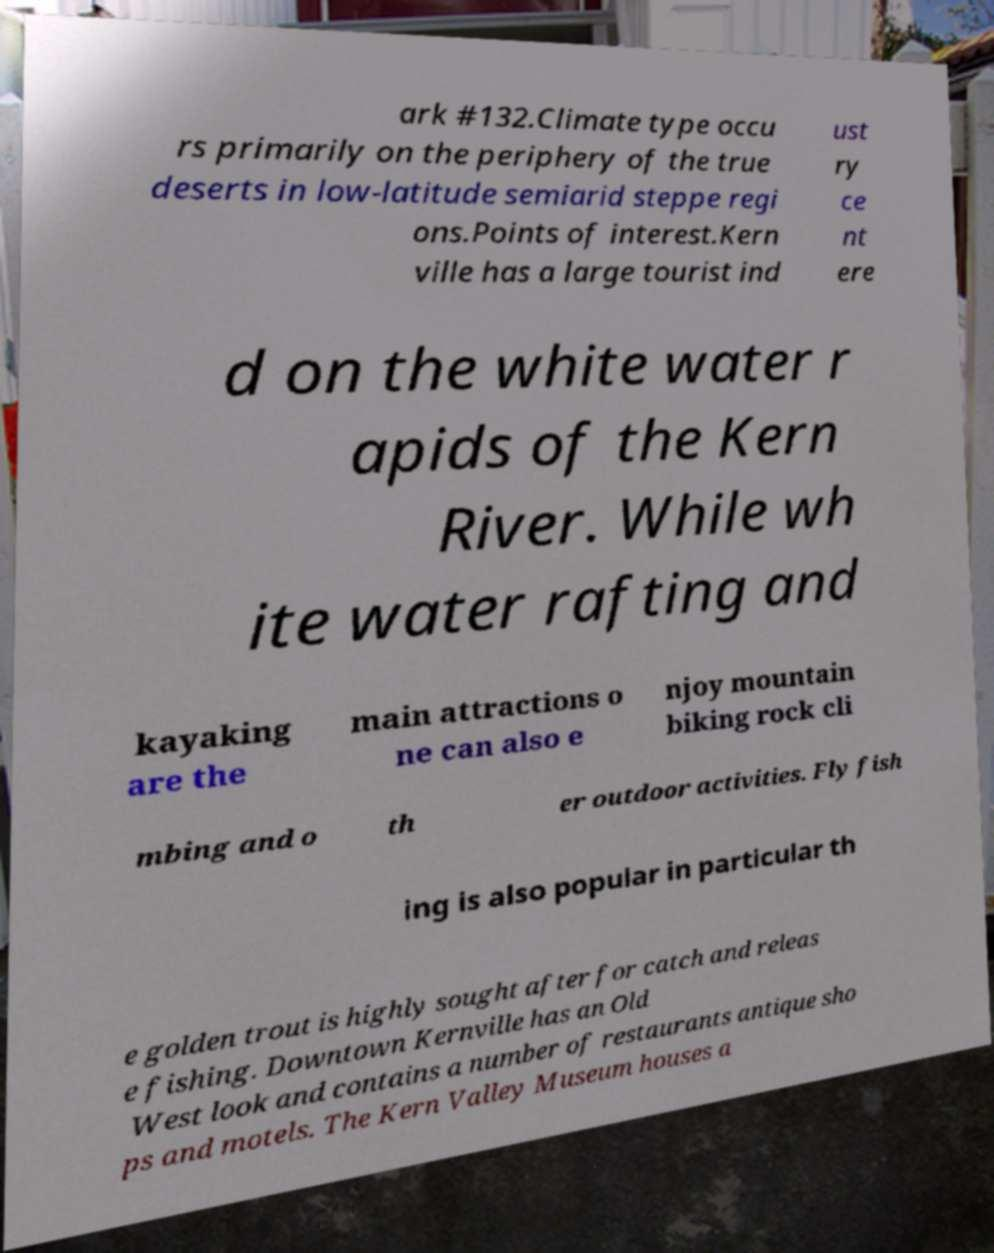What messages or text are displayed in this image? I need them in a readable, typed format. ark #132.Climate type occu rs primarily on the periphery of the true deserts in low-latitude semiarid steppe regi ons.Points of interest.Kern ville has a large tourist ind ust ry ce nt ere d on the white water r apids of the Kern River. While wh ite water rafting and kayaking are the main attractions o ne can also e njoy mountain biking rock cli mbing and o th er outdoor activities. Fly fish ing is also popular in particular th e golden trout is highly sought after for catch and releas e fishing. Downtown Kernville has an Old West look and contains a number of restaurants antique sho ps and motels. The Kern Valley Museum houses a 